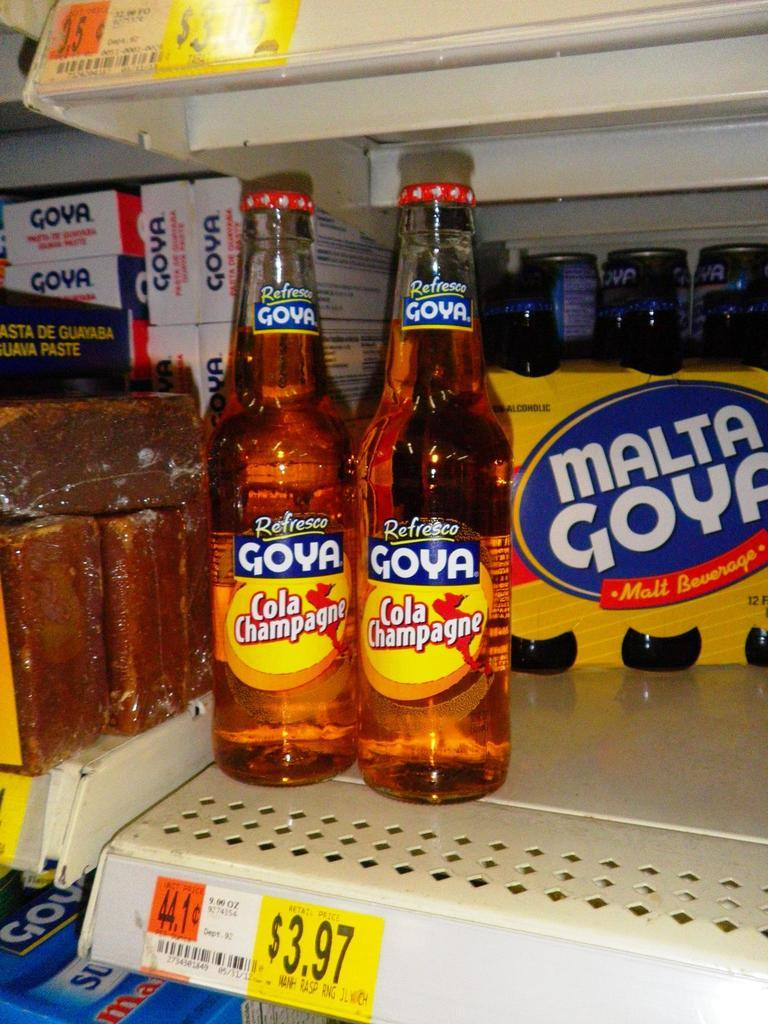<image>
Provide a brief description of the given image. Two bottles of Goya Cola Champagne sit on a shelf in front of other Goya products. 